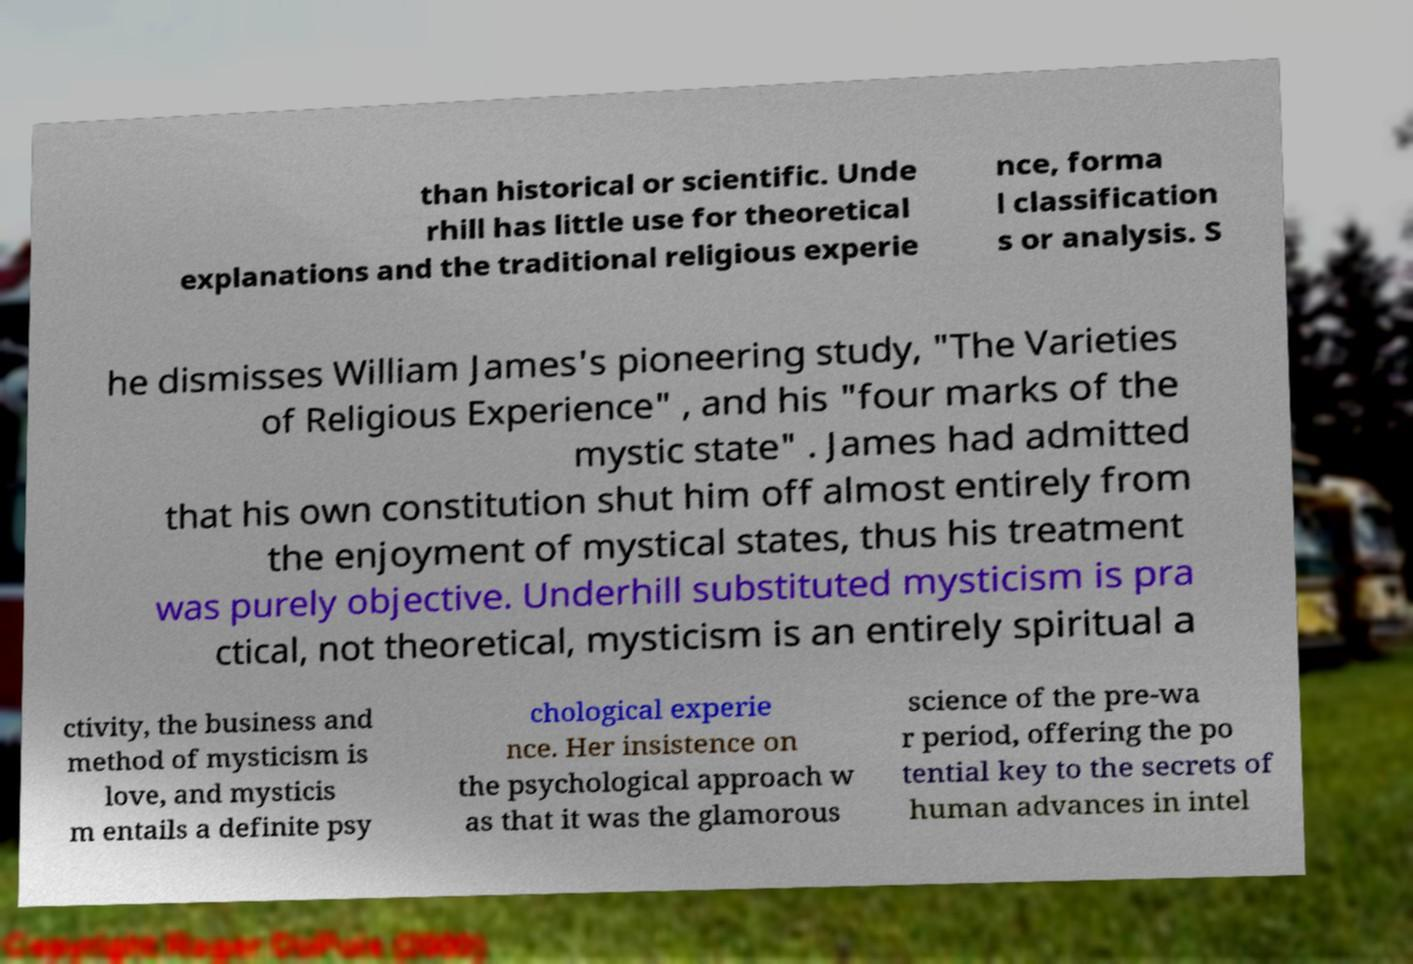There's text embedded in this image that I need extracted. Can you transcribe it verbatim? than historical or scientific. Unde rhill has little use for theoretical explanations and the traditional religious experie nce, forma l classification s or analysis. S he dismisses William James's pioneering study, "The Varieties of Religious Experience" , and his "four marks of the mystic state" . James had admitted that his own constitution shut him off almost entirely from the enjoyment of mystical states, thus his treatment was purely objective. Underhill substituted mysticism is pra ctical, not theoretical, mysticism is an entirely spiritual a ctivity, the business and method of mysticism is love, and mysticis m entails a definite psy chological experie nce. Her insistence on the psychological approach w as that it was the glamorous science of the pre-wa r period, offering the po tential key to the secrets of human advances in intel 